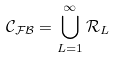Convert formula to latex. <formula><loc_0><loc_0><loc_500><loc_500>\mathcal { C _ { F B } } = \bigcup _ { L = 1 } ^ { \infty } \mathcal { R } _ { L }</formula> 